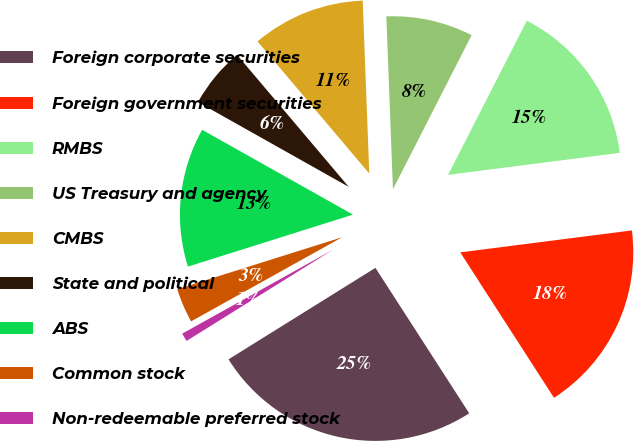Convert chart to OTSL. <chart><loc_0><loc_0><loc_500><loc_500><pie_chart><fcel>Foreign corporate securities<fcel>Foreign government securities<fcel>RMBS<fcel>US Treasury and agency<fcel>CMBS<fcel>State and political<fcel>ABS<fcel>Common stock<fcel>Non-redeemable preferred stock<nl><fcel>25.25%<fcel>17.91%<fcel>15.46%<fcel>8.12%<fcel>10.57%<fcel>5.67%<fcel>13.01%<fcel>3.23%<fcel>0.78%<nl></chart> 